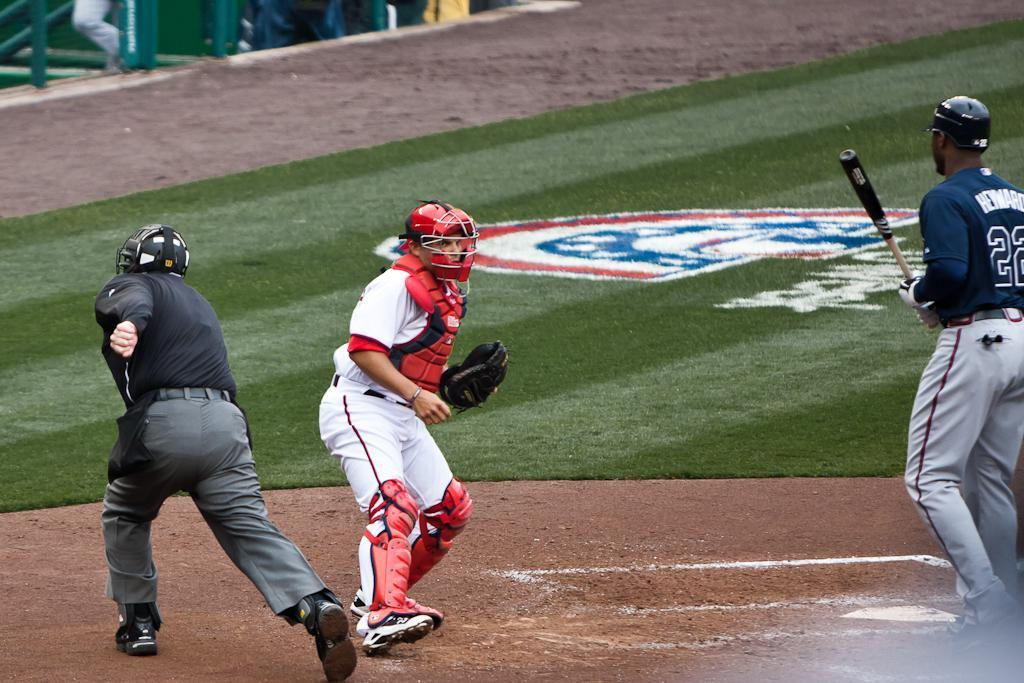<image>
Present a compact description of the photo's key features. Player number 22 holds a bat and wears a batting helmet. 